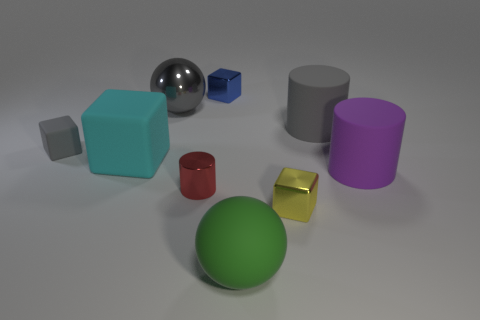What time of day does the lighting in the image suggest? The diffuse and soft shadows in the image suggest an ambient light source, possibly simulating an overcast day where shadows are less defined and the light is more even. 